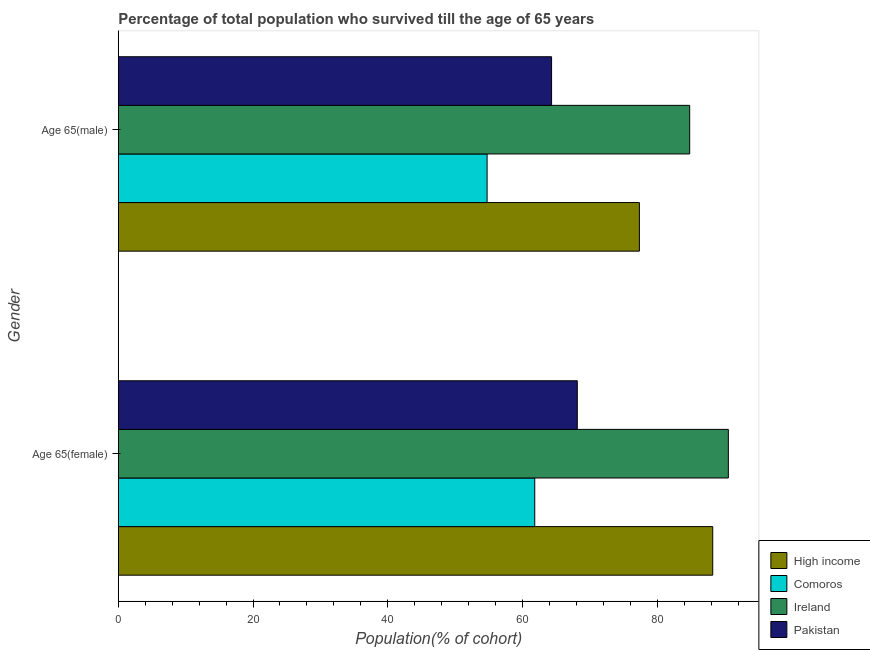How many different coloured bars are there?
Ensure brevity in your answer.  4. Are the number of bars per tick equal to the number of legend labels?
Offer a terse response. Yes. How many bars are there on the 1st tick from the bottom?
Give a very brief answer. 4. What is the label of the 2nd group of bars from the top?
Offer a terse response. Age 65(female). What is the percentage of male population who survived till age of 65 in Comoros?
Your response must be concise. 54.75. Across all countries, what is the maximum percentage of male population who survived till age of 65?
Ensure brevity in your answer.  84.82. Across all countries, what is the minimum percentage of female population who survived till age of 65?
Your answer should be very brief. 61.82. In which country was the percentage of female population who survived till age of 65 maximum?
Make the answer very short. Ireland. In which country was the percentage of female population who survived till age of 65 minimum?
Offer a very short reply. Comoros. What is the total percentage of male population who survived till age of 65 in the graph?
Provide a succinct answer. 281.24. What is the difference between the percentage of female population who survived till age of 65 in Ireland and that in Comoros?
Your response must be concise. 28.74. What is the difference between the percentage of male population who survived till age of 65 in Comoros and the percentage of female population who survived till age of 65 in Ireland?
Your answer should be compact. -35.81. What is the average percentage of male population who survived till age of 65 per country?
Your response must be concise. 70.31. What is the difference between the percentage of male population who survived till age of 65 and percentage of female population who survived till age of 65 in Comoros?
Provide a short and direct response. -7.07. In how many countries, is the percentage of male population who survived till age of 65 greater than 36 %?
Provide a succinct answer. 4. What is the ratio of the percentage of female population who survived till age of 65 in Pakistan to that in Ireland?
Offer a very short reply. 0.75. What does the 2nd bar from the top in Age 65(female) represents?
Your answer should be very brief. Ireland. What does the 2nd bar from the bottom in Age 65(female) represents?
Make the answer very short. Comoros. How many countries are there in the graph?
Your answer should be compact. 4. Are the values on the major ticks of X-axis written in scientific E-notation?
Your response must be concise. No. Does the graph contain any zero values?
Offer a terse response. No. Does the graph contain grids?
Offer a terse response. No. Where does the legend appear in the graph?
Keep it short and to the point. Bottom right. How are the legend labels stacked?
Your answer should be very brief. Vertical. What is the title of the graph?
Give a very brief answer. Percentage of total population who survived till the age of 65 years. What is the label or title of the X-axis?
Offer a terse response. Population(% of cohort). What is the Population(% of cohort) of High income in Age 65(female)?
Your answer should be very brief. 88.24. What is the Population(% of cohort) in Comoros in Age 65(female)?
Your response must be concise. 61.82. What is the Population(% of cohort) in Ireland in Age 65(female)?
Provide a short and direct response. 90.56. What is the Population(% of cohort) in Pakistan in Age 65(female)?
Your answer should be very brief. 68.14. What is the Population(% of cohort) of High income in Age 65(male)?
Offer a terse response. 77.35. What is the Population(% of cohort) in Comoros in Age 65(male)?
Offer a terse response. 54.75. What is the Population(% of cohort) of Ireland in Age 65(male)?
Offer a very short reply. 84.82. What is the Population(% of cohort) of Pakistan in Age 65(male)?
Your answer should be very brief. 64.32. Across all Gender, what is the maximum Population(% of cohort) of High income?
Your answer should be very brief. 88.24. Across all Gender, what is the maximum Population(% of cohort) in Comoros?
Make the answer very short. 61.82. Across all Gender, what is the maximum Population(% of cohort) in Ireland?
Your answer should be compact. 90.56. Across all Gender, what is the maximum Population(% of cohort) in Pakistan?
Give a very brief answer. 68.14. Across all Gender, what is the minimum Population(% of cohort) in High income?
Your answer should be compact. 77.35. Across all Gender, what is the minimum Population(% of cohort) in Comoros?
Your answer should be compact. 54.75. Across all Gender, what is the minimum Population(% of cohort) of Ireland?
Give a very brief answer. 84.82. Across all Gender, what is the minimum Population(% of cohort) of Pakistan?
Your response must be concise. 64.32. What is the total Population(% of cohort) of High income in the graph?
Provide a short and direct response. 165.59. What is the total Population(% of cohort) in Comoros in the graph?
Provide a succinct answer. 116.57. What is the total Population(% of cohort) in Ireland in the graph?
Provide a succinct answer. 175.38. What is the total Population(% of cohort) in Pakistan in the graph?
Your answer should be compact. 132.45. What is the difference between the Population(% of cohort) in High income in Age 65(female) and that in Age 65(male)?
Make the answer very short. 10.88. What is the difference between the Population(% of cohort) in Comoros in Age 65(female) and that in Age 65(male)?
Give a very brief answer. 7.07. What is the difference between the Population(% of cohort) in Ireland in Age 65(female) and that in Age 65(male)?
Offer a very short reply. 5.74. What is the difference between the Population(% of cohort) of Pakistan in Age 65(female) and that in Age 65(male)?
Your answer should be very brief. 3.82. What is the difference between the Population(% of cohort) of High income in Age 65(female) and the Population(% of cohort) of Comoros in Age 65(male)?
Make the answer very short. 33.49. What is the difference between the Population(% of cohort) of High income in Age 65(female) and the Population(% of cohort) of Ireland in Age 65(male)?
Make the answer very short. 3.42. What is the difference between the Population(% of cohort) of High income in Age 65(female) and the Population(% of cohort) of Pakistan in Age 65(male)?
Your response must be concise. 23.92. What is the difference between the Population(% of cohort) in Comoros in Age 65(female) and the Population(% of cohort) in Ireland in Age 65(male)?
Give a very brief answer. -23. What is the difference between the Population(% of cohort) in Comoros in Age 65(female) and the Population(% of cohort) in Pakistan in Age 65(male)?
Your response must be concise. -2.5. What is the difference between the Population(% of cohort) in Ireland in Age 65(female) and the Population(% of cohort) in Pakistan in Age 65(male)?
Give a very brief answer. 26.24. What is the average Population(% of cohort) in High income per Gender?
Your response must be concise. 82.8. What is the average Population(% of cohort) of Comoros per Gender?
Offer a terse response. 58.28. What is the average Population(% of cohort) in Ireland per Gender?
Your answer should be very brief. 87.69. What is the average Population(% of cohort) of Pakistan per Gender?
Give a very brief answer. 66.23. What is the difference between the Population(% of cohort) of High income and Population(% of cohort) of Comoros in Age 65(female)?
Ensure brevity in your answer.  26.42. What is the difference between the Population(% of cohort) of High income and Population(% of cohort) of Ireland in Age 65(female)?
Your response must be concise. -2.32. What is the difference between the Population(% of cohort) of High income and Population(% of cohort) of Pakistan in Age 65(female)?
Your answer should be very brief. 20.1. What is the difference between the Population(% of cohort) of Comoros and Population(% of cohort) of Ireland in Age 65(female)?
Ensure brevity in your answer.  -28.74. What is the difference between the Population(% of cohort) of Comoros and Population(% of cohort) of Pakistan in Age 65(female)?
Your answer should be compact. -6.32. What is the difference between the Population(% of cohort) of Ireland and Population(% of cohort) of Pakistan in Age 65(female)?
Offer a terse response. 22.42. What is the difference between the Population(% of cohort) in High income and Population(% of cohort) in Comoros in Age 65(male)?
Offer a terse response. 22.61. What is the difference between the Population(% of cohort) in High income and Population(% of cohort) in Ireland in Age 65(male)?
Keep it short and to the point. -7.46. What is the difference between the Population(% of cohort) in High income and Population(% of cohort) in Pakistan in Age 65(male)?
Provide a succinct answer. 13.04. What is the difference between the Population(% of cohort) of Comoros and Population(% of cohort) of Ireland in Age 65(male)?
Your response must be concise. -30.07. What is the difference between the Population(% of cohort) of Comoros and Population(% of cohort) of Pakistan in Age 65(male)?
Offer a terse response. -9.57. What is the difference between the Population(% of cohort) in Ireland and Population(% of cohort) in Pakistan in Age 65(male)?
Offer a very short reply. 20.5. What is the ratio of the Population(% of cohort) in High income in Age 65(female) to that in Age 65(male)?
Your answer should be compact. 1.14. What is the ratio of the Population(% of cohort) of Comoros in Age 65(female) to that in Age 65(male)?
Offer a terse response. 1.13. What is the ratio of the Population(% of cohort) in Ireland in Age 65(female) to that in Age 65(male)?
Offer a very short reply. 1.07. What is the ratio of the Population(% of cohort) of Pakistan in Age 65(female) to that in Age 65(male)?
Your answer should be compact. 1.06. What is the difference between the highest and the second highest Population(% of cohort) of High income?
Your answer should be compact. 10.88. What is the difference between the highest and the second highest Population(% of cohort) in Comoros?
Give a very brief answer. 7.07. What is the difference between the highest and the second highest Population(% of cohort) in Ireland?
Ensure brevity in your answer.  5.74. What is the difference between the highest and the second highest Population(% of cohort) in Pakistan?
Give a very brief answer. 3.82. What is the difference between the highest and the lowest Population(% of cohort) in High income?
Offer a very short reply. 10.88. What is the difference between the highest and the lowest Population(% of cohort) in Comoros?
Your answer should be compact. 7.07. What is the difference between the highest and the lowest Population(% of cohort) of Ireland?
Provide a short and direct response. 5.74. What is the difference between the highest and the lowest Population(% of cohort) of Pakistan?
Your answer should be compact. 3.82. 